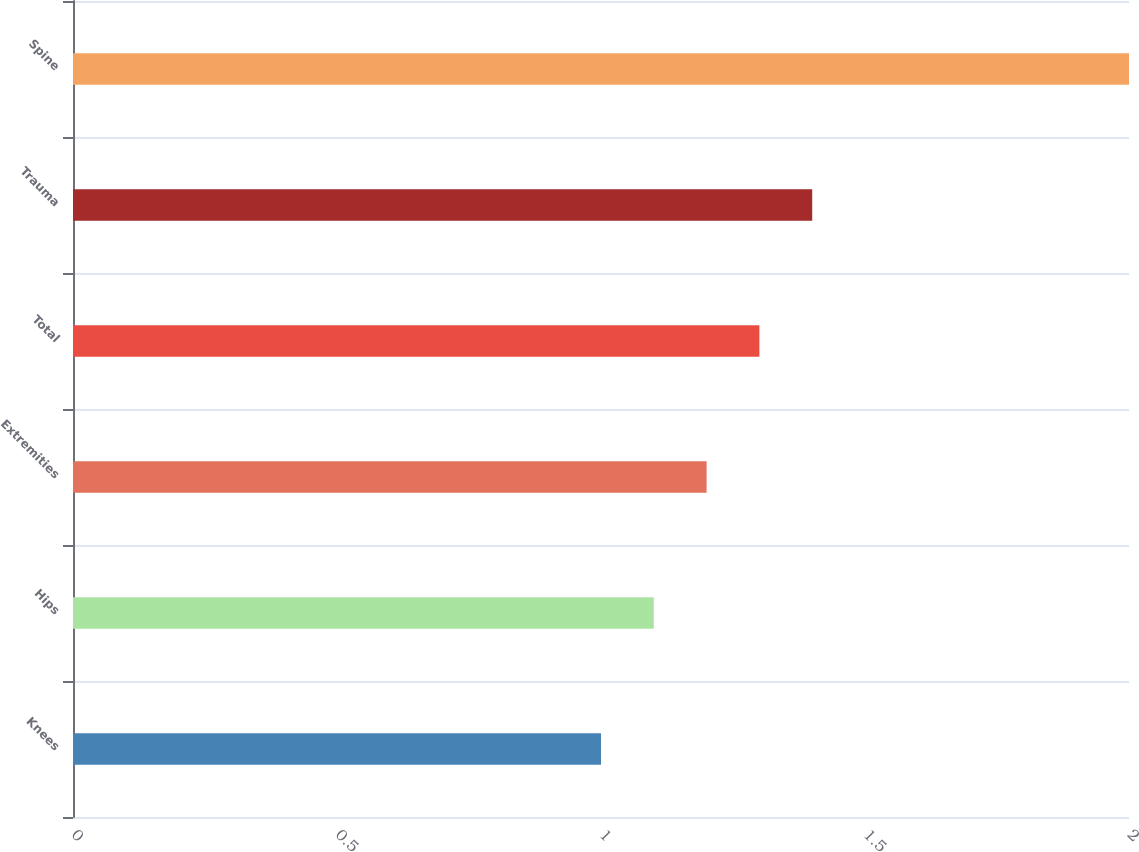Convert chart to OTSL. <chart><loc_0><loc_0><loc_500><loc_500><bar_chart><fcel>Knees<fcel>Hips<fcel>Extremities<fcel>Total<fcel>Trauma<fcel>Spine<nl><fcel>1<fcel>1.1<fcel>1.2<fcel>1.3<fcel>1.4<fcel>2<nl></chart> 